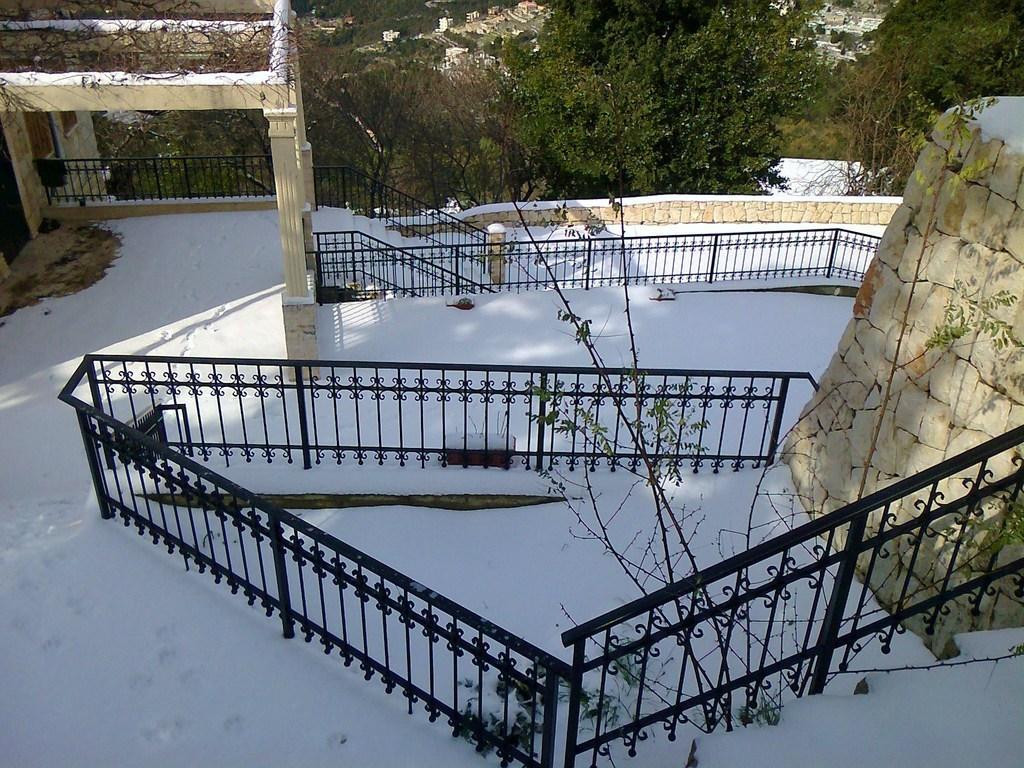In one or two sentences, can you explain what this image depicts? In this image there is a building with fence covered with snow, beside that there are so many trees and buildings. 